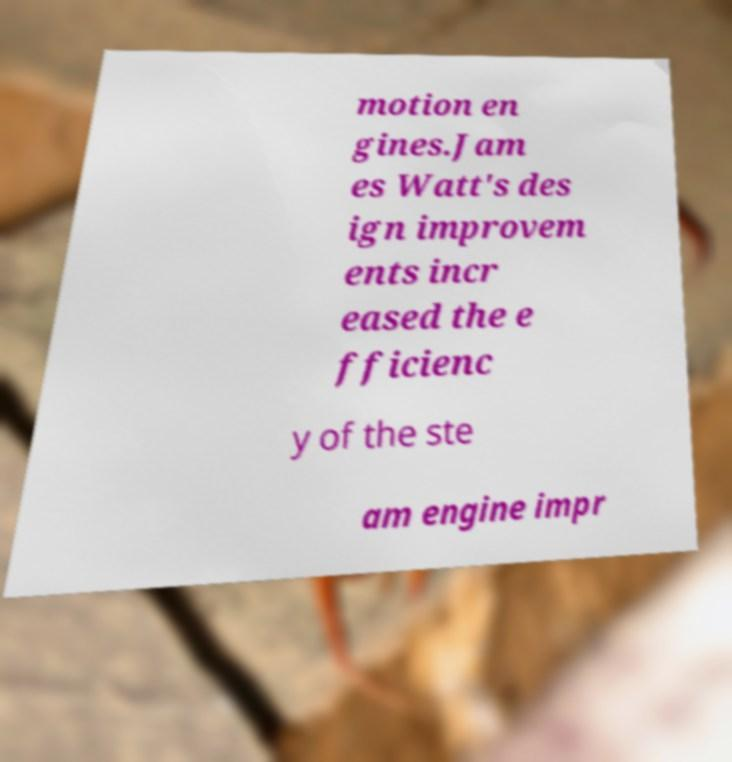Please identify and transcribe the text found in this image. motion en gines.Jam es Watt's des ign improvem ents incr eased the e fficienc y of the ste am engine impr 